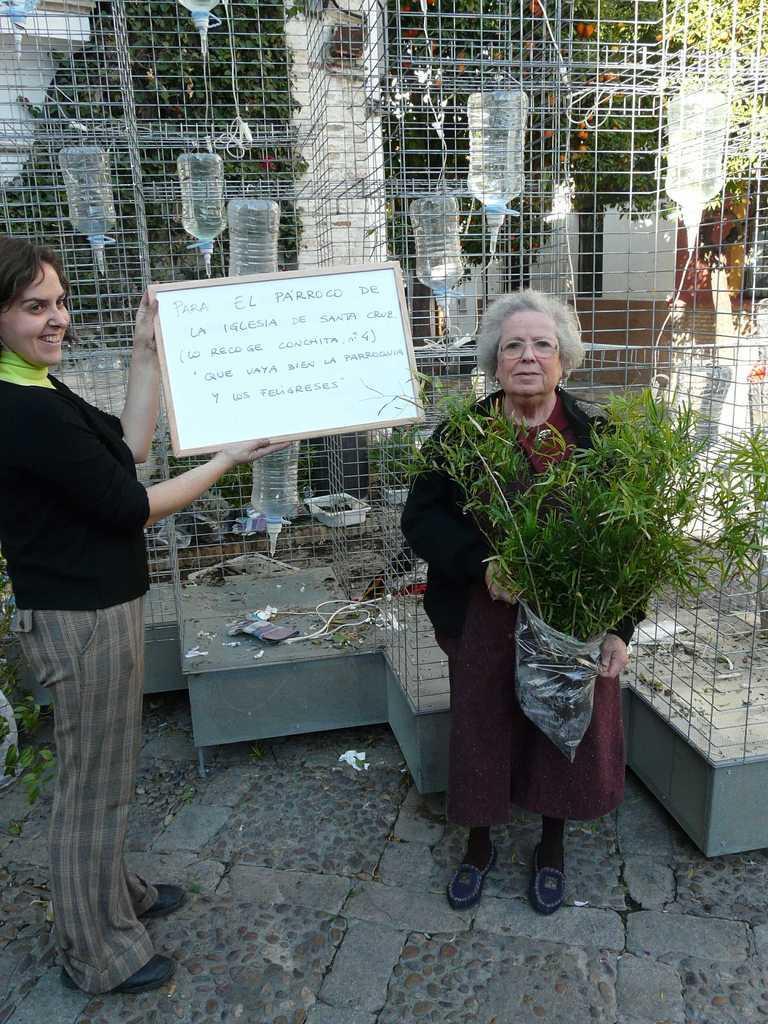Describe this image in one or two sentences. In the picture we can see a path to it, we can see a woman standing, holding a white color board and she is smiling and beside her we can see another woman standing and holding a plant and behind them, we can see a fencing wall behind it we can see some water cans which are hanged upside down with some pipes to it. 